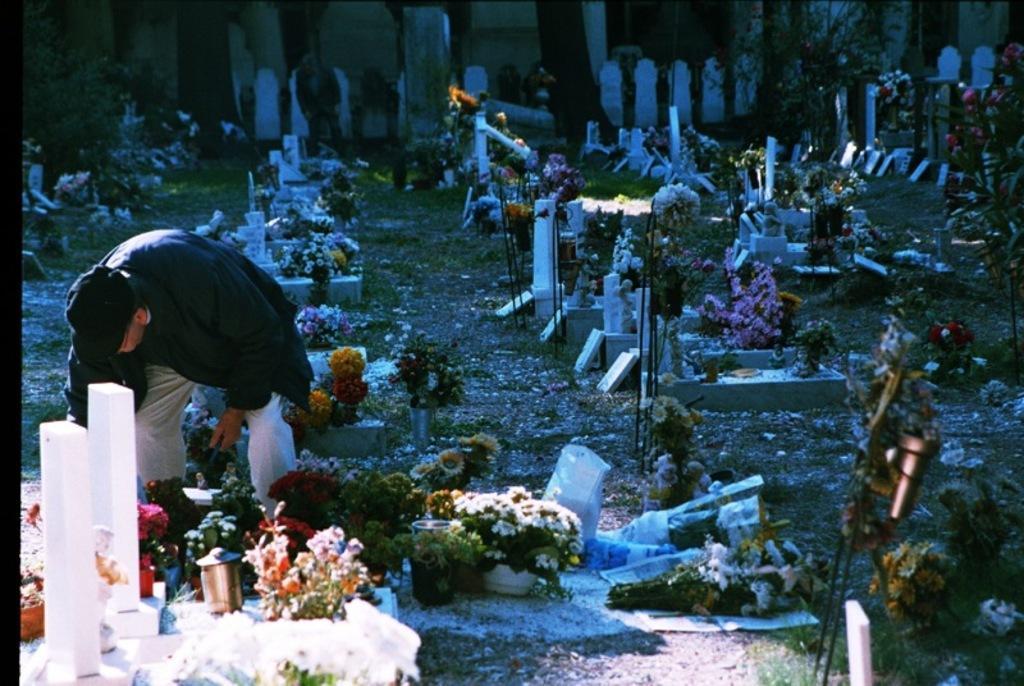Please provide a concise description of this image. This image is consists of a graveyard and there are flowers and candles on every grave and there is a man who is bending towards the ground on the left side of the image. 